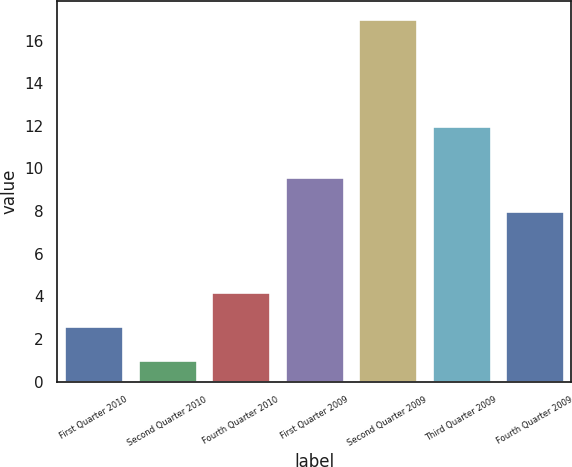<chart> <loc_0><loc_0><loc_500><loc_500><bar_chart><fcel>First Quarter 2010<fcel>Second Quarter 2010<fcel>Fourth Quarter 2010<fcel>First Quarter 2009<fcel>Second Quarter 2009<fcel>Third Quarter 2009<fcel>Fourth Quarter 2009<nl><fcel>2.6<fcel>1<fcel>4.2<fcel>9.6<fcel>17<fcel>12<fcel>8<nl></chart> 